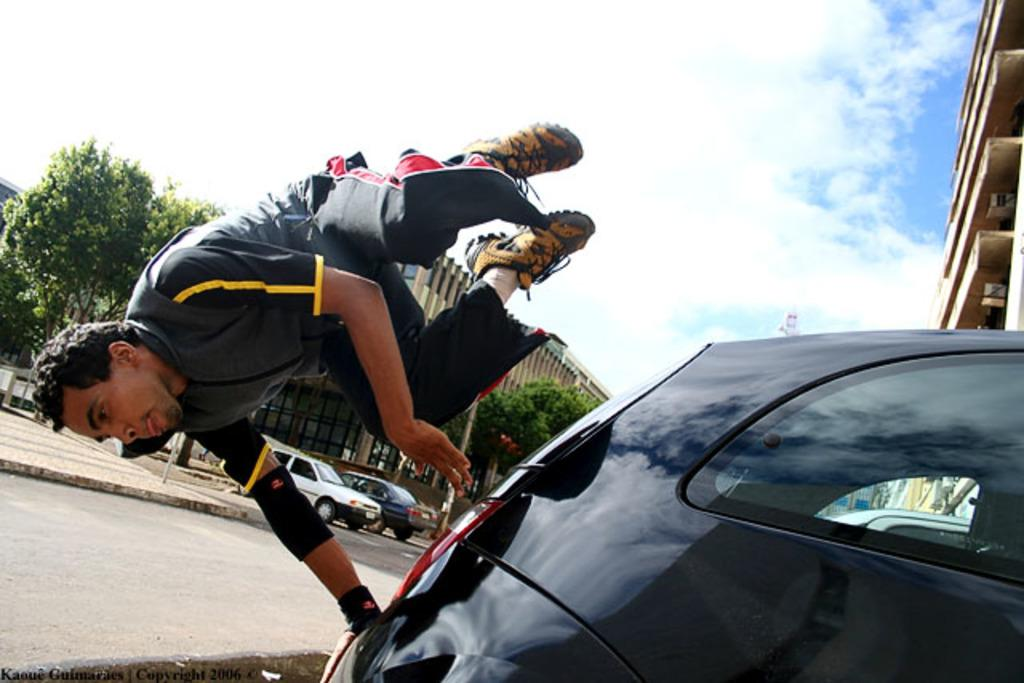What is the person in the image doing? There is a person in the air in the image, which suggests they might be flying or jumping. What can be seen to the right of the person? There are vehicles to the right of the person. What is visible in the background of the image? There are buildings, trees, and the sky visible in the background of the image. How many types of objects can be seen in the background? There are at least three types of objects visible in the background: buildings, trees, and vehicles. How many pencils are being used to solve the riddle in the image? There is no riddle or pencil present in the image. What is the amount of money the person in the image is holding? There is no indication of money or any financial transaction in the image. 